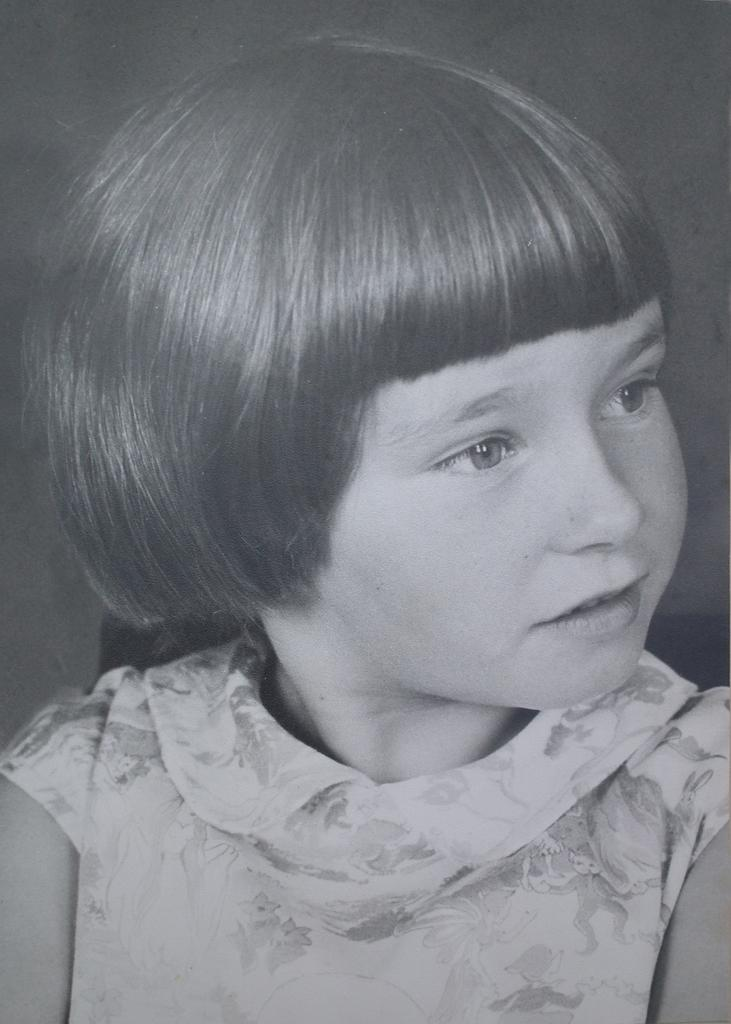What is the color scheme of the image? The image is black and white. Can you describe the main subject of the image? There is a girl in the image. What type of heat source can be seen in the image? There is no heat source present in the image. What is the girl doing with the brake in the image? There is no brake present in the image, and the girl is not performing any actions related to a brake. 